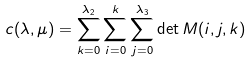Convert formula to latex. <formula><loc_0><loc_0><loc_500><loc_500>c ( \lambda , \mu ) = \sum _ { k = 0 } ^ { \lambda _ { 2 } } \sum _ { i = 0 } ^ { k } \sum _ { j = 0 } ^ { \lambda _ { 3 } } \det M ( i , j , k )</formula> 